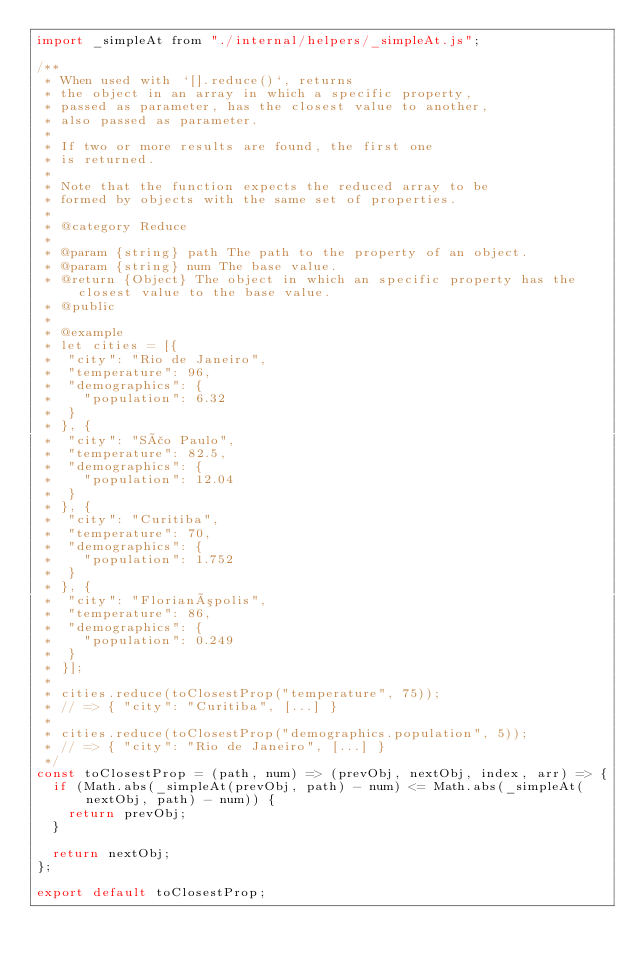<code> <loc_0><loc_0><loc_500><loc_500><_JavaScript_>import _simpleAt from "./internal/helpers/_simpleAt.js";

/**
 * When used with `[].reduce()`, returns
 * the object in an array in which a specific property,
 * passed as parameter, has the closest value to another,
 * also passed as parameter.
 *
 * If two or more results are found, the first one
 * is returned.
 *
 * Note that the function expects the reduced array to be
 * formed by objects with the same set of properties.
 *
 * @category Reduce
 *
 * @param {string} path The path to the property of an object.
 * @param {string} num The base value.
 * @return {Object} The object in which an specific property has the closest value to the base value.
 * @public
 *
 * @example
 * let cities = [{
 * 	"city": "Rio de Janeiro",
 * 	"temperature": 96,
 * 	"demographics": {
 * 		"population": 6.32
 * 	}
 * }, {
 * 	"city": "São Paulo",
 * 	"temperature": 82.5,
 * 	"demographics": {
 * 		"population": 12.04
 * 	}
 * }, {
 * 	"city": "Curitiba",
 * 	"temperature": 70,
 * 	"demographics": {
 * 		"population": 1.752
 * 	}
 * }, {
 * 	"city": "Florianópolis",
 * 	"temperature": 86,
 * 	"demographics": {
 * 		"population": 0.249
 * 	}
 * }];
 *
 * cities.reduce(toClosestProp("temperature", 75));
 * // => { "city": "Curitiba", [...] }
 *
 * cities.reduce(toClosestProp("demographics.population", 5));
 * // => { "city": "Rio de Janeiro", [...] }
 */
const toClosestProp = (path, num) => (prevObj, nextObj, index, arr) => {
	if (Math.abs(_simpleAt(prevObj, path) - num) <= Math.abs(_simpleAt(nextObj, path) - num)) {
		return prevObj;
	}

	return nextObj;
};

export default toClosestProp;
</code> 